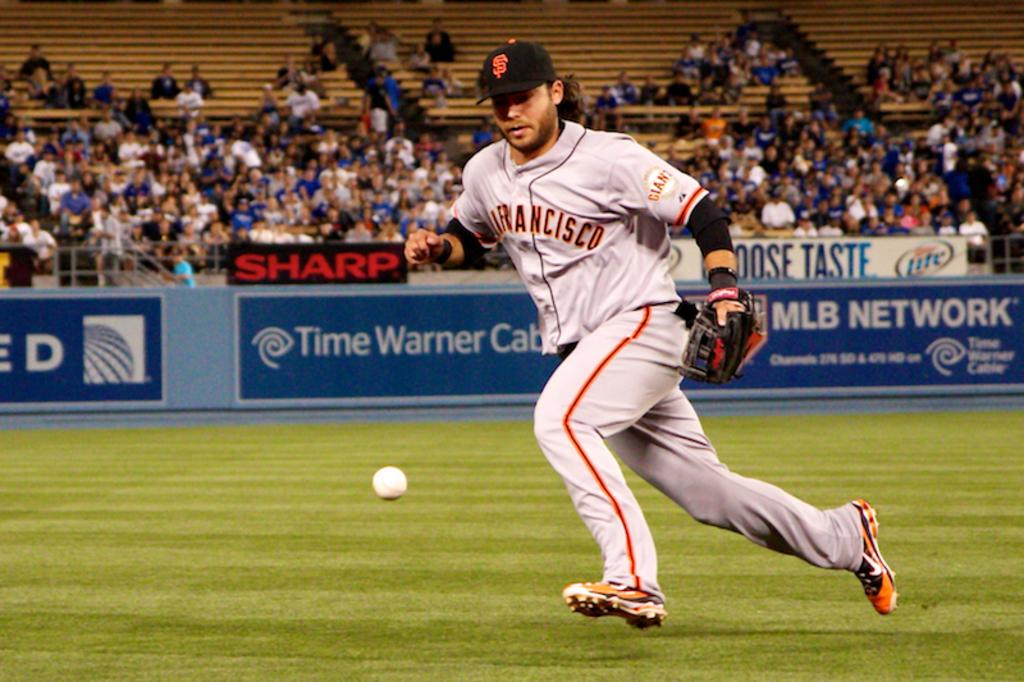<image>
Give a short and clear explanation of the subsequent image. A San Francisco baseball player is going after a ball. 